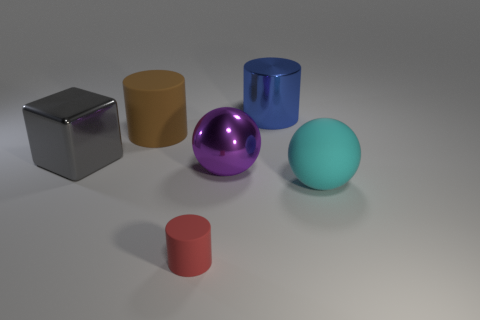Subtract all tiny red matte cylinders. How many cylinders are left? 2 Add 2 tiny gray shiny balls. How many objects exist? 8 Subtract all brown cylinders. How many cylinders are left? 2 Subtract all balls. How many objects are left? 4 Subtract all yellow spheres. Subtract all blue cylinders. How many spheres are left? 2 Subtract all big brown things. Subtract all red metal cylinders. How many objects are left? 5 Add 6 metal cylinders. How many metal cylinders are left? 7 Add 1 red matte cylinders. How many red matte cylinders exist? 2 Subtract 0 red balls. How many objects are left? 6 Subtract 1 blocks. How many blocks are left? 0 